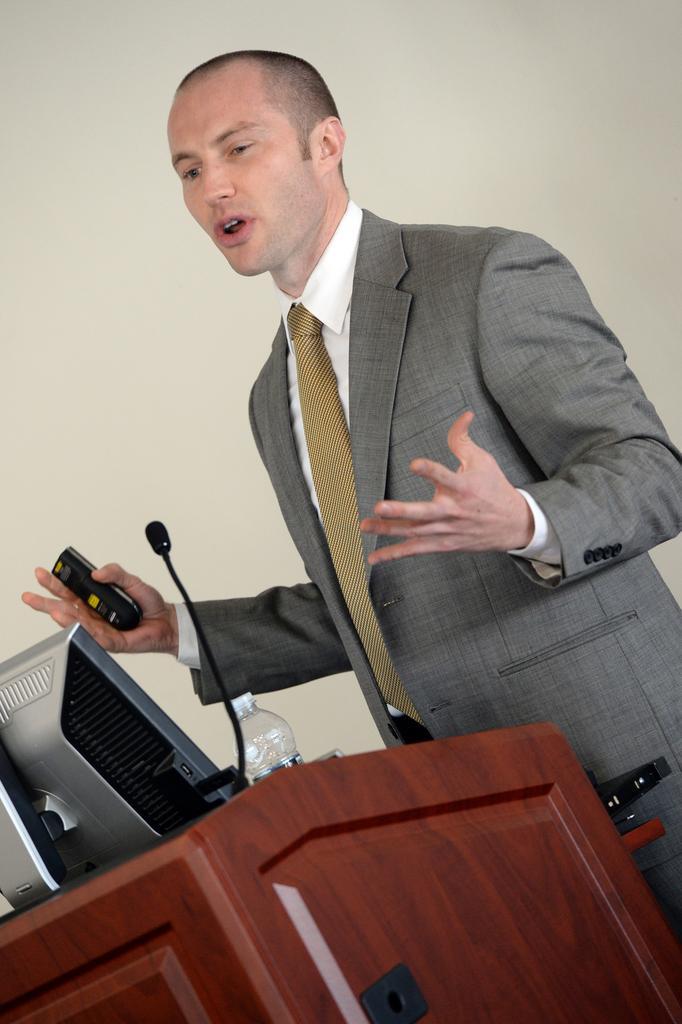In one or two sentences, can you explain what this image depicts? In this image, there is a wearing clothes and standing in front of the podium. This podium contains bottle, mic and monitor. This person is holding remote with his hand. 